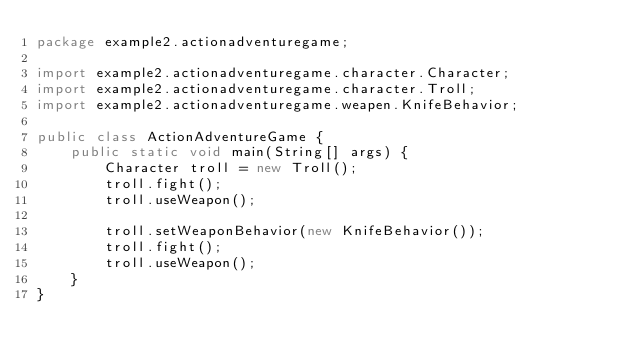<code> <loc_0><loc_0><loc_500><loc_500><_Java_>package example2.actionadventuregame;

import example2.actionadventuregame.character.Character;
import example2.actionadventuregame.character.Troll;
import example2.actionadventuregame.weapen.KnifeBehavior;

public class ActionAdventureGame {
    public static void main(String[] args) {
        Character troll = new Troll();
        troll.fight();
        troll.useWeapon();

        troll.setWeaponBehavior(new KnifeBehavior());
        troll.fight();
        troll.useWeapon();
    }
}
</code> 